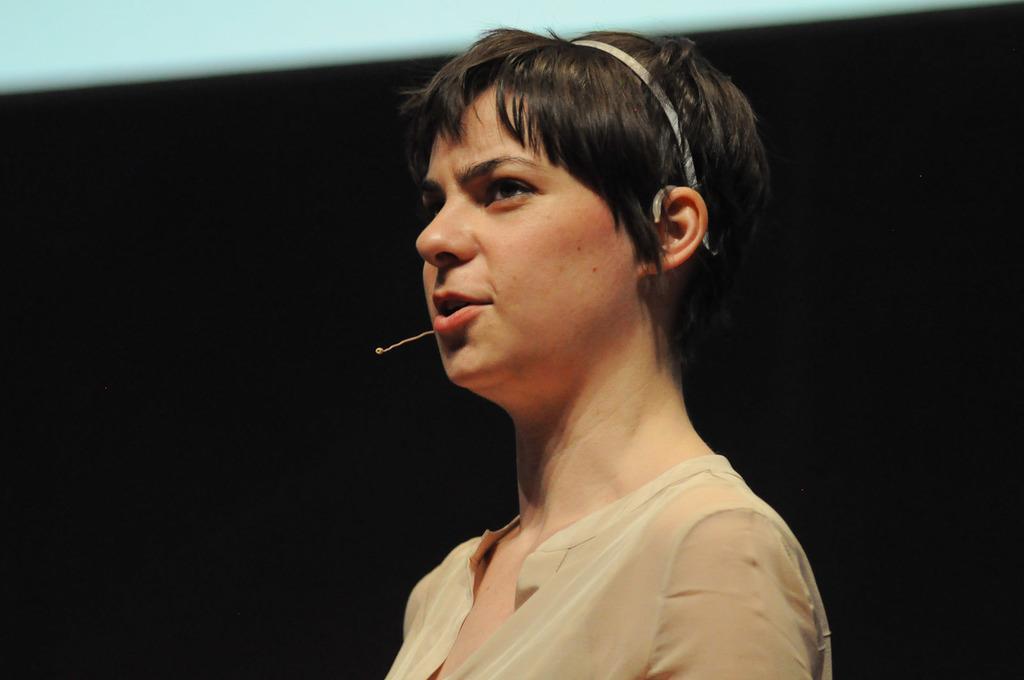Could you give a brief overview of what you see in this image? In this image we can see a lady at the center of the image is talking and there is a microphone in front of her, the background is dark. 